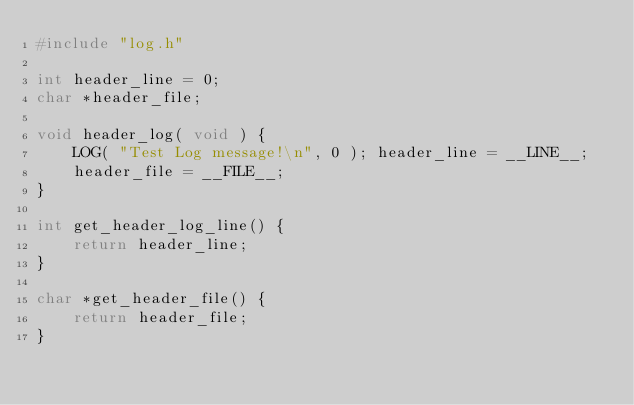Convert code to text. <code><loc_0><loc_0><loc_500><loc_500><_C_>#include "log.h"

int header_line = 0;
char *header_file;

void header_log( void ) {
    LOG( "Test Log message!\n", 0 ); header_line = __LINE__;
    header_file = __FILE__;
}

int get_header_log_line() {
    return header_line;
}

char *get_header_file() {
    return header_file;
}
</code> 